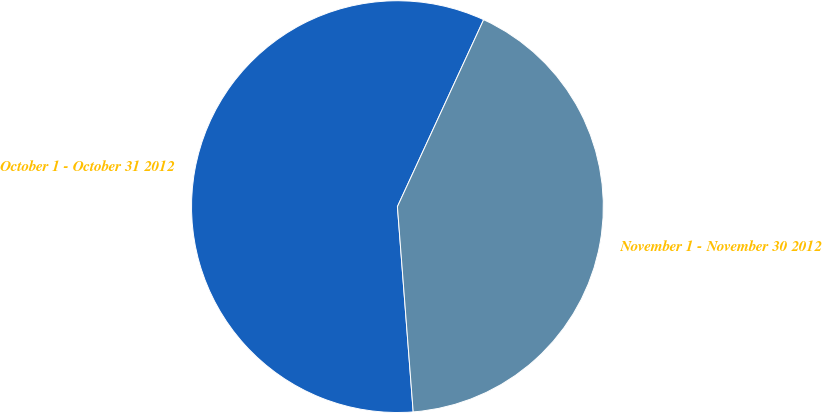Convert chart. <chart><loc_0><loc_0><loc_500><loc_500><pie_chart><fcel>October 1 - October 31 2012<fcel>November 1 - November 30 2012<nl><fcel>58.1%<fcel>41.9%<nl></chart> 